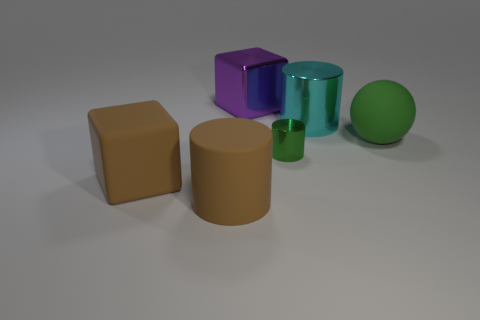There is a cylinder that is the same color as the rubber block; what is it made of? If a cylinder shares the same color as the rubber block, it's likely made of a similar material; however, without additional context, such as texture or reflection properties, color alone does not definitively determine material composition. The cylinder could possibly be made of rubber, or it may simply be painted to match the rubber block's hue. 